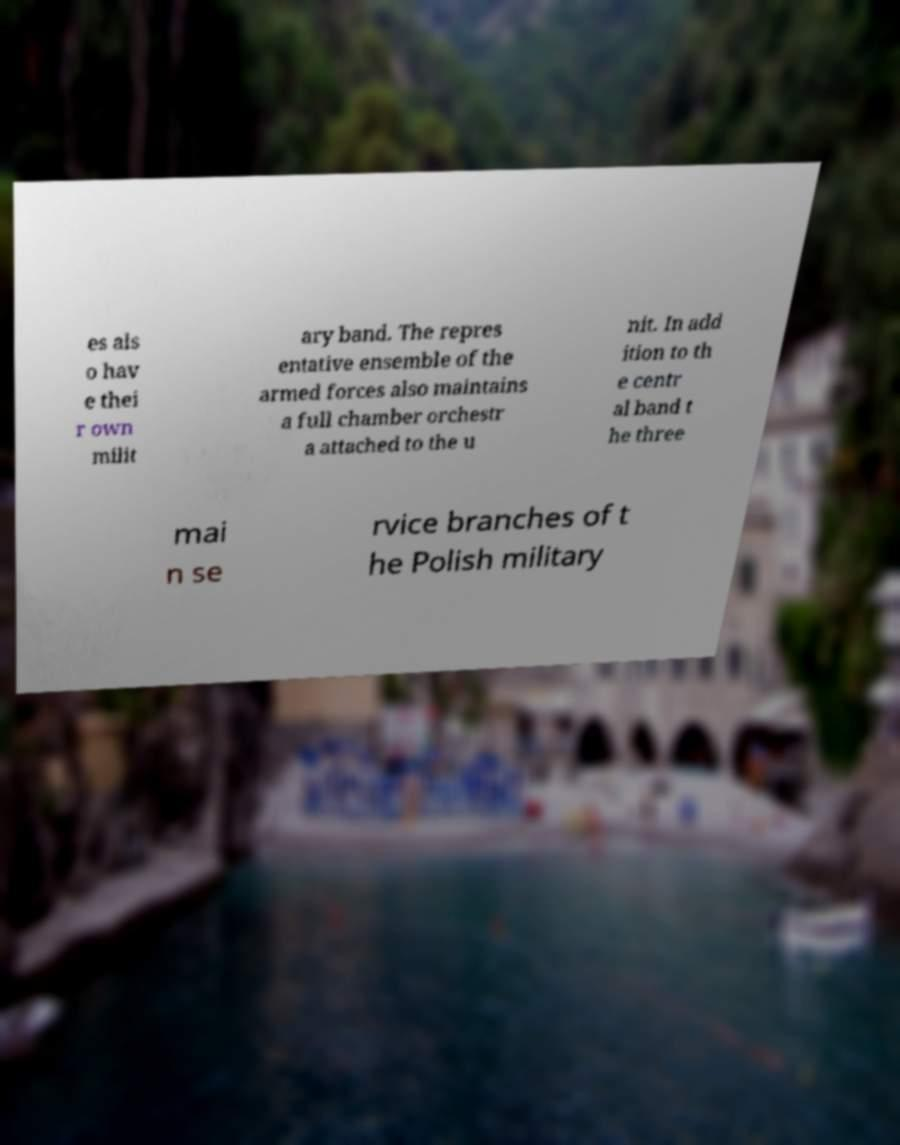Can you accurately transcribe the text from the provided image for me? es als o hav e thei r own milit ary band. The repres entative ensemble of the armed forces also maintains a full chamber orchestr a attached to the u nit. In add ition to th e centr al band t he three mai n se rvice branches of t he Polish military 